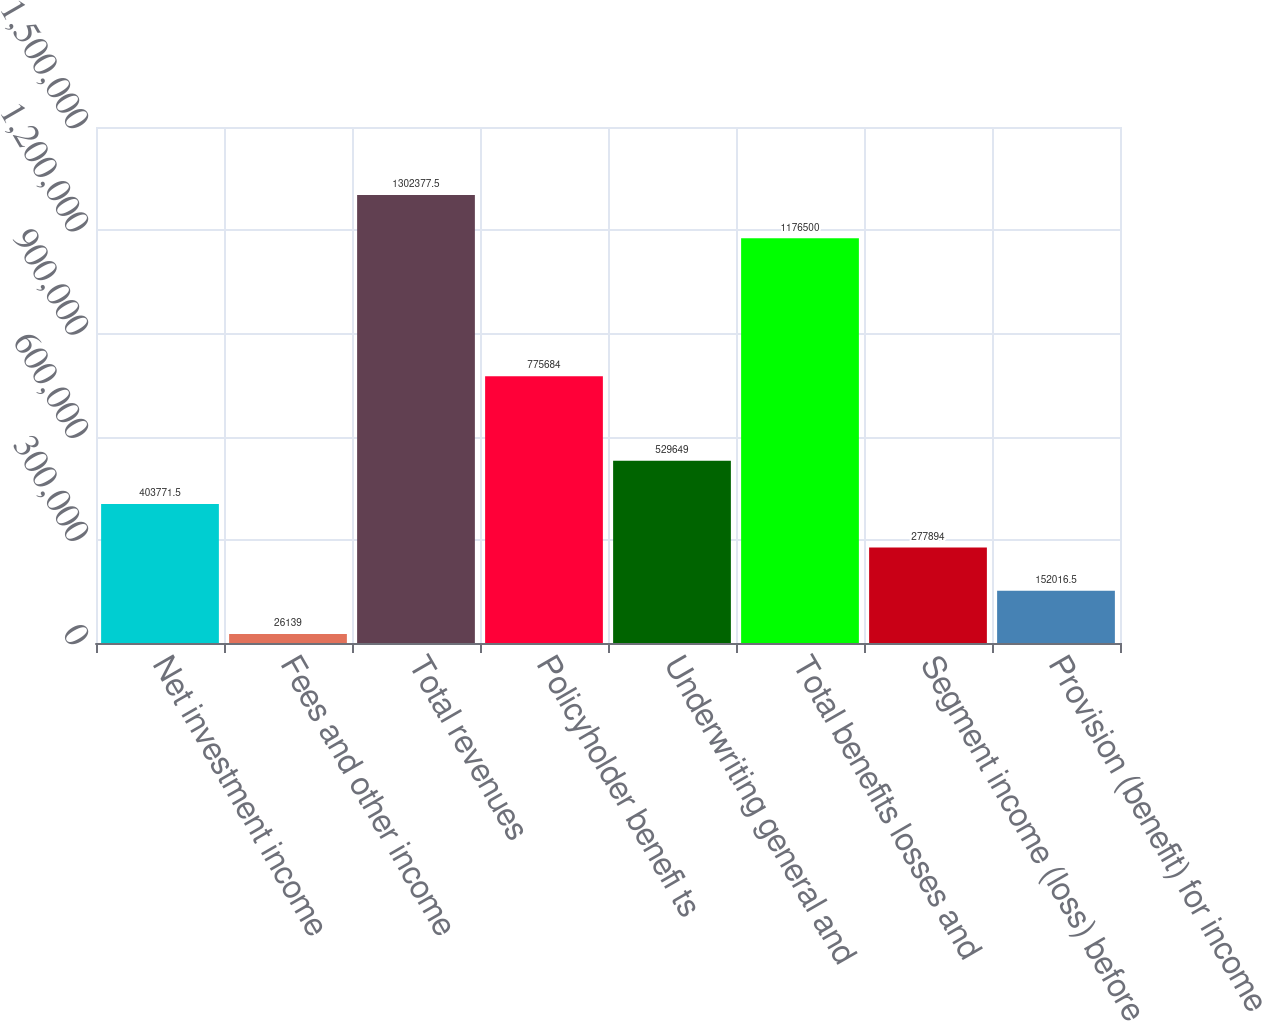Convert chart. <chart><loc_0><loc_0><loc_500><loc_500><bar_chart><fcel>Net investment income<fcel>Fees and other income<fcel>Total revenues<fcel>Policyholder benefi ts<fcel>Underwriting general and<fcel>Total benefits losses and<fcel>Segment income (loss) before<fcel>Provision (benefit) for income<nl><fcel>403772<fcel>26139<fcel>1.30238e+06<fcel>775684<fcel>529649<fcel>1.1765e+06<fcel>277894<fcel>152016<nl></chart> 